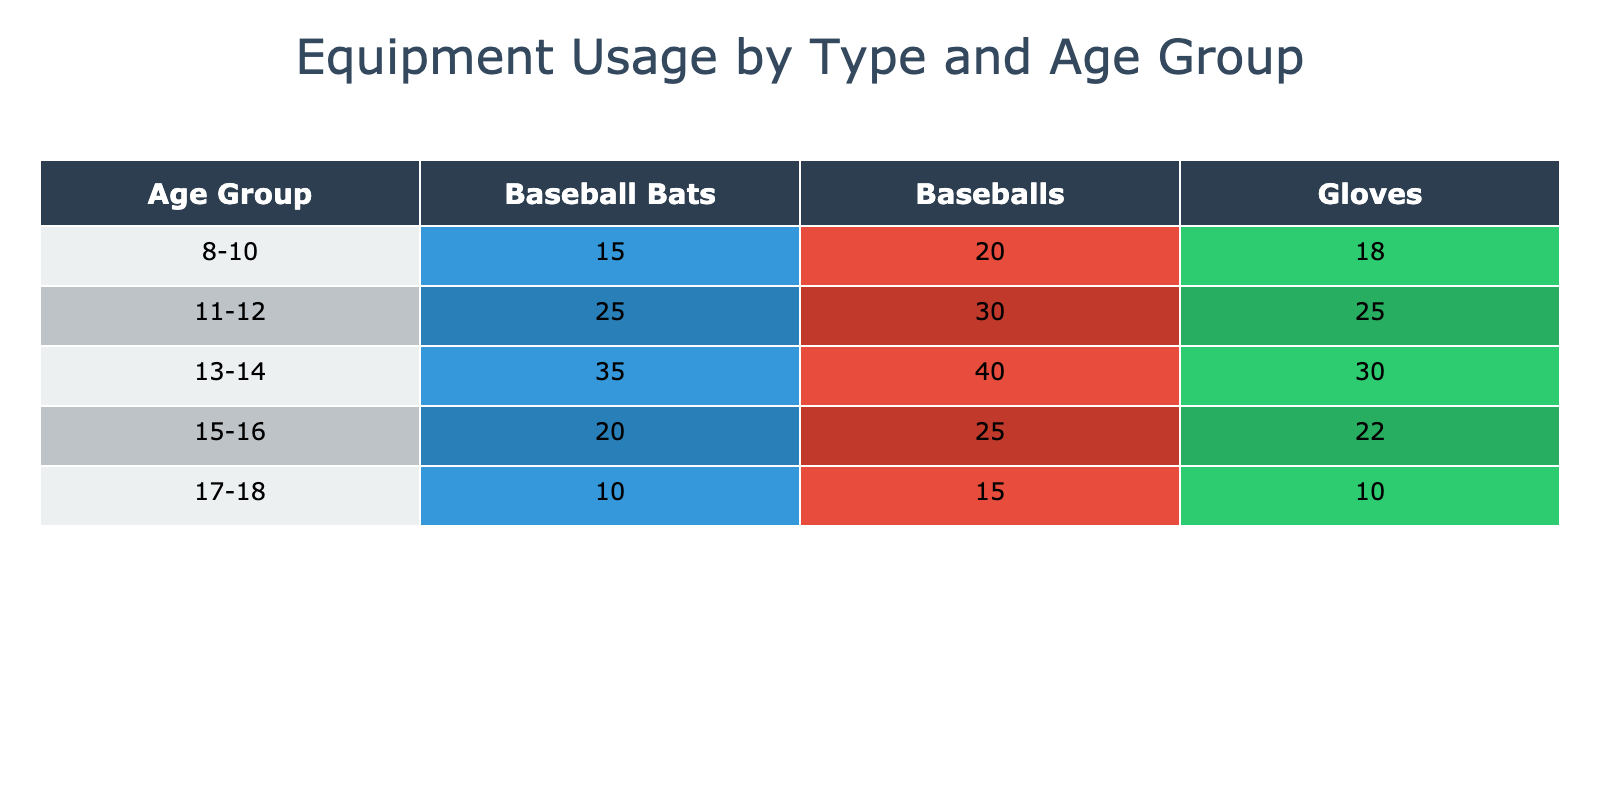What is the total number of baseball bats used by the 11-12 age group? In the table, the value for baseball bats under the 11-12 age group is 25. Therefore, the total number of baseball bats used by this age group is simply the value listed in the table.
Answer: 25 Which age group uses the most gloves? By looking at the values in the gloves column, the age group 11-12 uses 25 gloves, while all other age groups use either fewer or an equal amount. Thus, the highest number of gloves is 25, and the corresponding age group is 11-12.
Answer: 11-12 What is the average number of baseballs used across all age groups? To calculate the average, sum the values in the baseballs column: 20 + 30 + 40 + 25 + 15 = 130. There are 5 age groups, so the average is 130 divided by 5, which equals 26.
Answer: 26 Is there a decrease in the usage of baseball bats as the age group increases from 8-10 to 17-18? Looking at the baseball bats column, the values for age groups 8-10, 11-12, and 13-14 are 15, 25, and 35, respectively, which increases. However, in the age groups 15-16 and 17-18, the values decrease to 20 and 10. This indicates that there is indeed a decrease in usage as the age progresses from 8-10 to 17-18.
Answer: Yes How many more baseballs are used in the 13-14 age group compared to the 17-18 age group? The number of baseballs used by the 13-14 age group is 40, while the 17-18 age group uses 15 baseballs. Subtracting 15 from 40 gives us 25 more baseballs used by the 13-14 age group compared to the 17-18 age group.
Answer: 25 